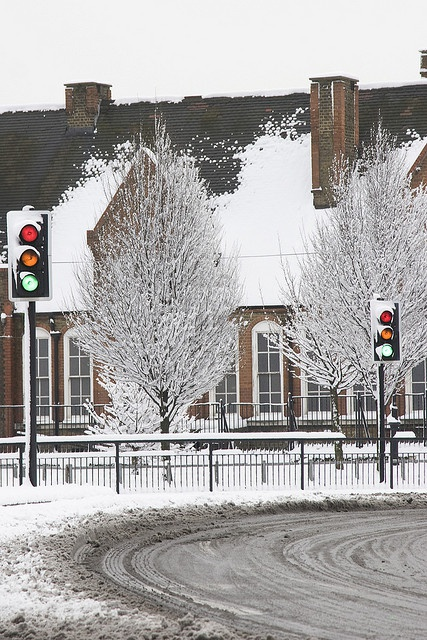Describe the objects in this image and their specific colors. I can see traffic light in white, lightgray, black, darkgray, and gray tones and traffic light in white, lightgray, black, gray, and darkgray tones in this image. 